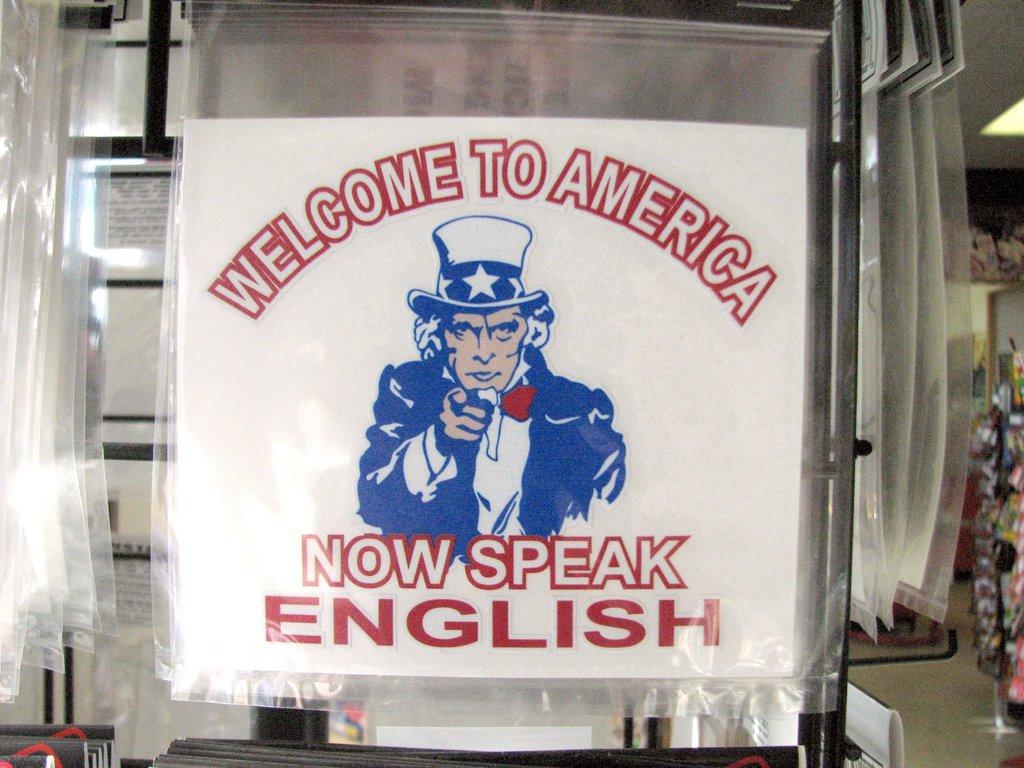What does it want you to speak?
Keep it short and to the point. English. Where is this welcoming you to?
Offer a very short reply. America. 